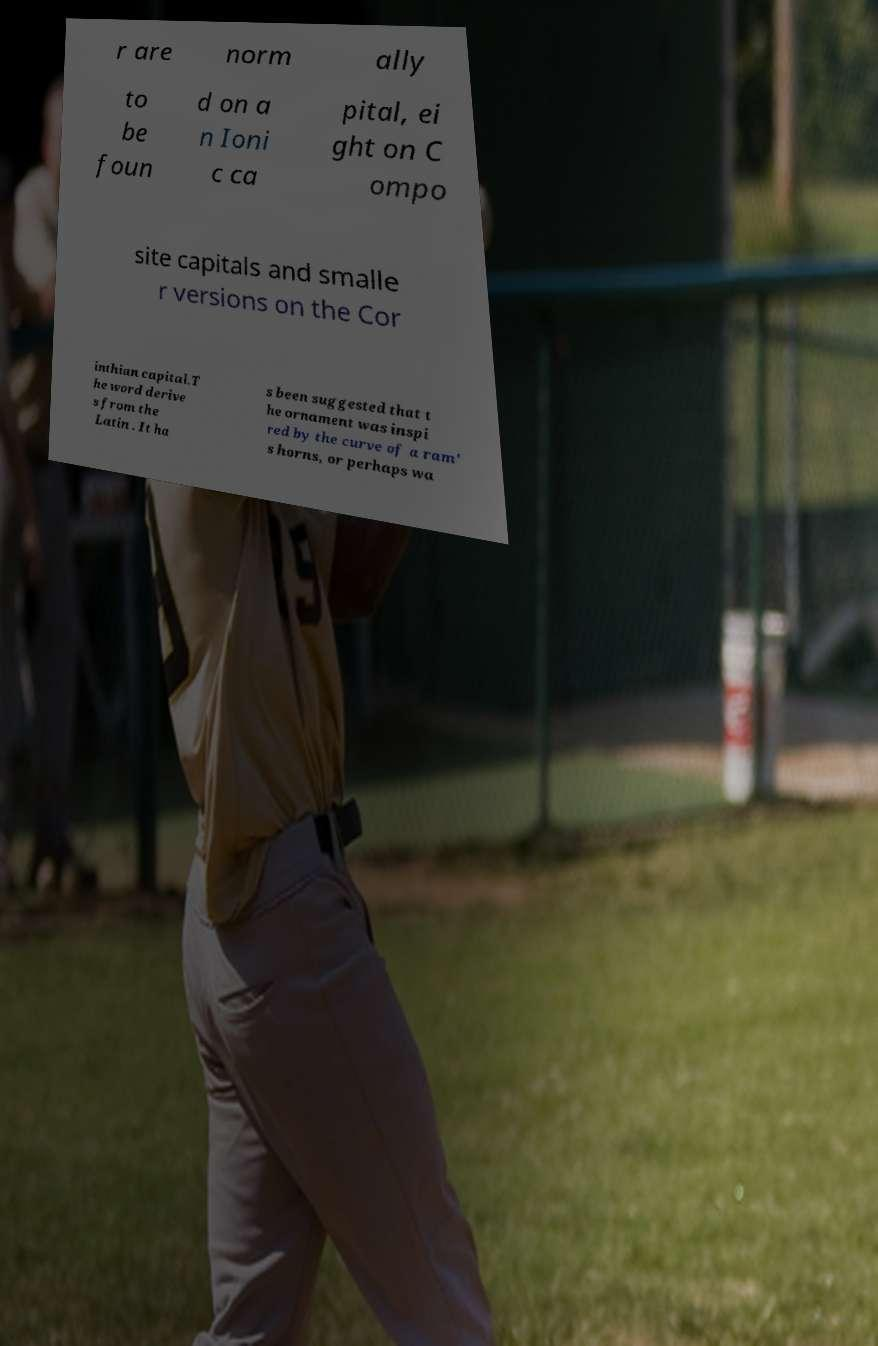Can you accurately transcribe the text from the provided image for me? r are norm ally to be foun d on a n Ioni c ca pital, ei ght on C ompo site capitals and smalle r versions on the Cor inthian capital.T he word derive s from the Latin . It ha s been suggested that t he ornament was inspi red by the curve of a ram' s horns, or perhaps wa 